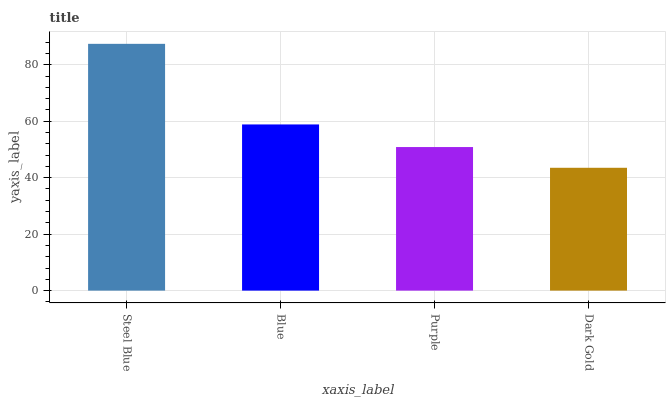Is Dark Gold the minimum?
Answer yes or no. Yes. Is Steel Blue the maximum?
Answer yes or no. Yes. Is Blue the minimum?
Answer yes or no. No. Is Blue the maximum?
Answer yes or no. No. Is Steel Blue greater than Blue?
Answer yes or no. Yes. Is Blue less than Steel Blue?
Answer yes or no. Yes. Is Blue greater than Steel Blue?
Answer yes or no. No. Is Steel Blue less than Blue?
Answer yes or no. No. Is Blue the high median?
Answer yes or no. Yes. Is Purple the low median?
Answer yes or no. Yes. Is Purple the high median?
Answer yes or no. No. Is Blue the low median?
Answer yes or no. No. 